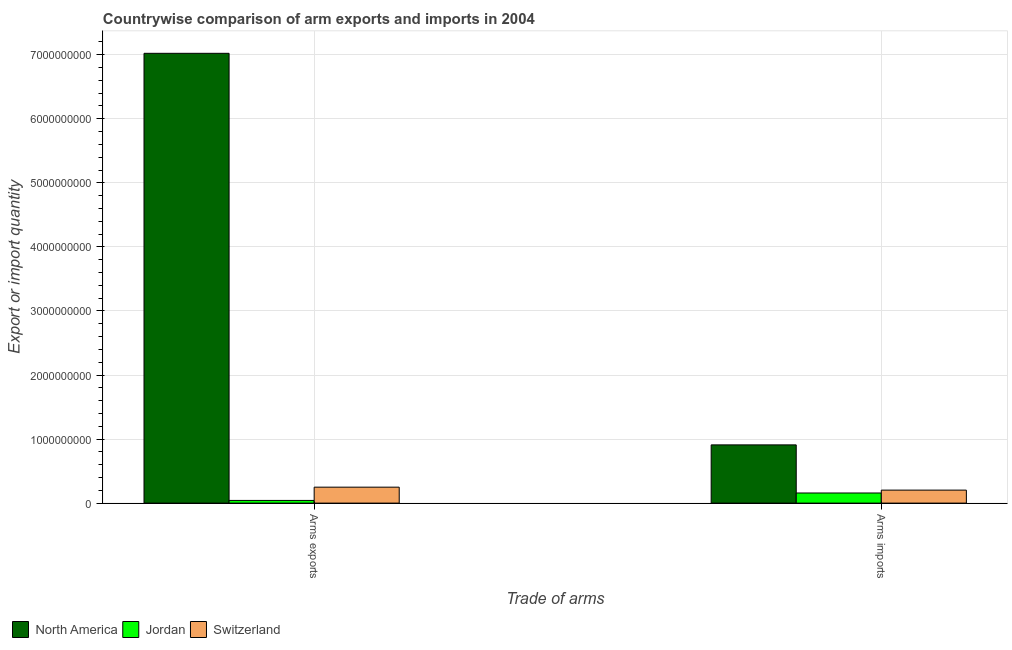How many different coloured bars are there?
Ensure brevity in your answer.  3. How many groups of bars are there?
Offer a very short reply. 2. Are the number of bars per tick equal to the number of legend labels?
Your response must be concise. Yes. Are the number of bars on each tick of the X-axis equal?
Provide a succinct answer. Yes. What is the label of the 1st group of bars from the left?
Provide a succinct answer. Arms exports. What is the arms exports in North America?
Your answer should be very brief. 7.02e+09. Across all countries, what is the maximum arms exports?
Keep it short and to the point. 7.02e+09. Across all countries, what is the minimum arms exports?
Keep it short and to the point. 4.20e+07. In which country was the arms imports maximum?
Your response must be concise. North America. In which country was the arms exports minimum?
Provide a succinct answer. Jordan. What is the total arms imports in the graph?
Your answer should be compact. 1.27e+09. What is the difference between the arms imports in Switzerland and that in Jordan?
Your answer should be compact. 4.50e+07. What is the difference between the arms exports in Switzerland and the arms imports in North America?
Your answer should be very brief. -6.60e+08. What is the average arms exports per country?
Make the answer very short. 2.44e+09. What is the difference between the arms imports and arms exports in Jordan?
Make the answer very short. 1.16e+08. In how many countries, is the arms imports greater than 2600000000 ?
Provide a short and direct response. 0. What is the ratio of the arms imports in Switzerland to that in Jordan?
Your answer should be very brief. 1.28. Is the arms imports in Jordan less than that in North America?
Keep it short and to the point. Yes. What does the 2nd bar from the right in Arms imports represents?
Offer a terse response. Jordan. What is the difference between two consecutive major ticks on the Y-axis?
Provide a succinct answer. 1.00e+09. How are the legend labels stacked?
Give a very brief answer. Horizontal. What is the title of the graph?
Offer a very short reply. Countrywise comparison of arm exports and imports in 2004. Does "Liechtenstein" appear as one of the legend labels in the graph?
Give a very brief answer. No. What is the label or title of the X-axis?
Your answer should be compact. Trade of arms. What is the label or title of the Y-axis?
Provide a succinct answer. Export or import quantity. What is the Export or import quantity of North America in Arms exports?
Your answer should be very brief. 7.02e+09. What is the Export or import quantity of Jordan in Arms exports?
Provide a short and direct response. 4.20e+07. What is the Export or import quantity in Switzerland in Arms exports?
Make the answer very short. 2.49e+08. What is the Export or import quantity in North America in Arms imports?
Give a very brief answer. 9.09e+08. What is the Export or import quantity in Jordan in Arms imports?
Your response must be concise. 1.58e+08. What is the Export or import quantity in Switzerland in Arms imports?
Provide a succinct answer. 2.03e+08. Across all Trade of arms, what is the maximum Export or import quantity of North America?
Provide a succinct answer. 7.02e+09. Across all Trade of arms, what is the maximum Export or import quantity of Jordan?
Your answer should be very brief. 1.58e+08. Across all Trade of arms, what is the maximum Export or import quantity of Switzerland?
Offer a terse response. 2.49e+08. Across all Trade of arms, what is the minimum Export or import quantity of North America?
Provide a short and direct response. 9.09e+08. Across all Trade of arms, what is the minimum Export or import quantity of Jordan?
Ensure brevity in your answer.  4.20e+07. Across all Trade of arms, what is the minimum Export or import quantity of Switzerland?
Ensure brevity in your answer.  2.03e+08. What is the total Export or import quantity in North America in the graph?
Provide a short and direct response. 7.93e+09. What is the total Export or import quantity of Jordan in the graph?
Offer a very short reply. 2.00e+08. What is the total Export or import quantity in Switzerland in the graph?
Ensure brevity in your answer.  4.52e+08. What is the difference between the Export or import quantity of North America in Arms exports and that in Arms imports?
Provide a short and direct response. 6.11e+09. What is the difference between the Export or import quantity of Jordan in Arms exports and that in Arms imports?
Make the answer very short. -1.16e+08. What is the difference between the Export or import quantity of Switzerland in Arms exports and that in Arms imports?
Ensure brevity in your answer.  4.60e+07. What is the difference between the Export or import quantity of North America in Arms exports and the Export or import quantity of Jordan in Arms imports?
Ensure brevity in your answer.  6.86e+09. What is the difference between the Export or import quantity in North America in Arms exports and the Export or import quantity in Switzerland in Arms imports?
Ensure brevity in your answer.  6.82e+09. What is the difference between the Export or import quantity of Jordan in Arms exports and the Export or import quantity of Switzerland in Arms imports?
Offer a very short reply. -1.61e+08. What is the average Export or import quantity in North America per Trade of arms?
Your answer should be compact. 3.97e+09. What is the average Export or import quantity in Jordan per Trade of arms?
Provide a succinct answer. 1.00e+08. What is the average Export or import quantity in Switzerland per Trade of arms?
Your response must be concise. 2.26e+08. What is the difference between the Export or import quantity in North America and Export or import quantity in Jordan in Arms exports?
Provide a succinct answer. 6.98e+09. What is the difference between the Export or import quantity of North America and Export or import quantity of Switzerland in Arms exports?
Your answer should be very brief. 6.77e+09. What is the difference between the Export or import quantity in Jordan and Export or import quantity in Switzerland in Arms exports?
Provide a short and direct response. -2.07e+08. What is the difference between the Export or import quantity of North America and Export or import quantity of Jordan in Arms imports?
Your answer should be compact. 7.51e+08. What is the difference between the Export or import quantity of North America and Export or import quantity of Switzerland in Arms imports?
Give a very brief answer. 7.06e+08. What is the difference between the Export or import quantity in Jordan and Export or import quantity in Switzerland in Arms imports?
Ensure brevity in your answer.  -4.50e+07. What is the ratio of the Export or import quantity in North America in Arms exports to that in Arms imports?
Provide a succinct answer. 7.72. What is the ratio of the Export or import quantity of Jordan in Arms exports to that in Arms imports?
Offer a very short reply. 0.27. What is the ratio of the Export or import quantity of Switzerland in Arms exports to that in Arms imports?
Provide a short and direct response. 1.23. What is the difference between the highest and the second highest Export or import quantity in North America?
Your answer should be compact. 6.11e+09. What is the difference between the highest and the second highest Export or import quantity in Jordan?
Your answer should be compact. 1.16e+08. What is the difference between the highest and the second highest Export or import quantity of Switzerland?
Provide a succinct answer. 4.60e+07. What is the difference between the highest and the lowest Export or import quantity in North America?
Your answer should be compact. 6.11e+09. What is the difference between the highest and the lowest Export or import quantity of Jordan?
Your response must be concise. 1.16e+08. What is the difference between the highest and the lowest Export or import quantity in Switzerland?
Offer a very short reply. 4.60e+07. 